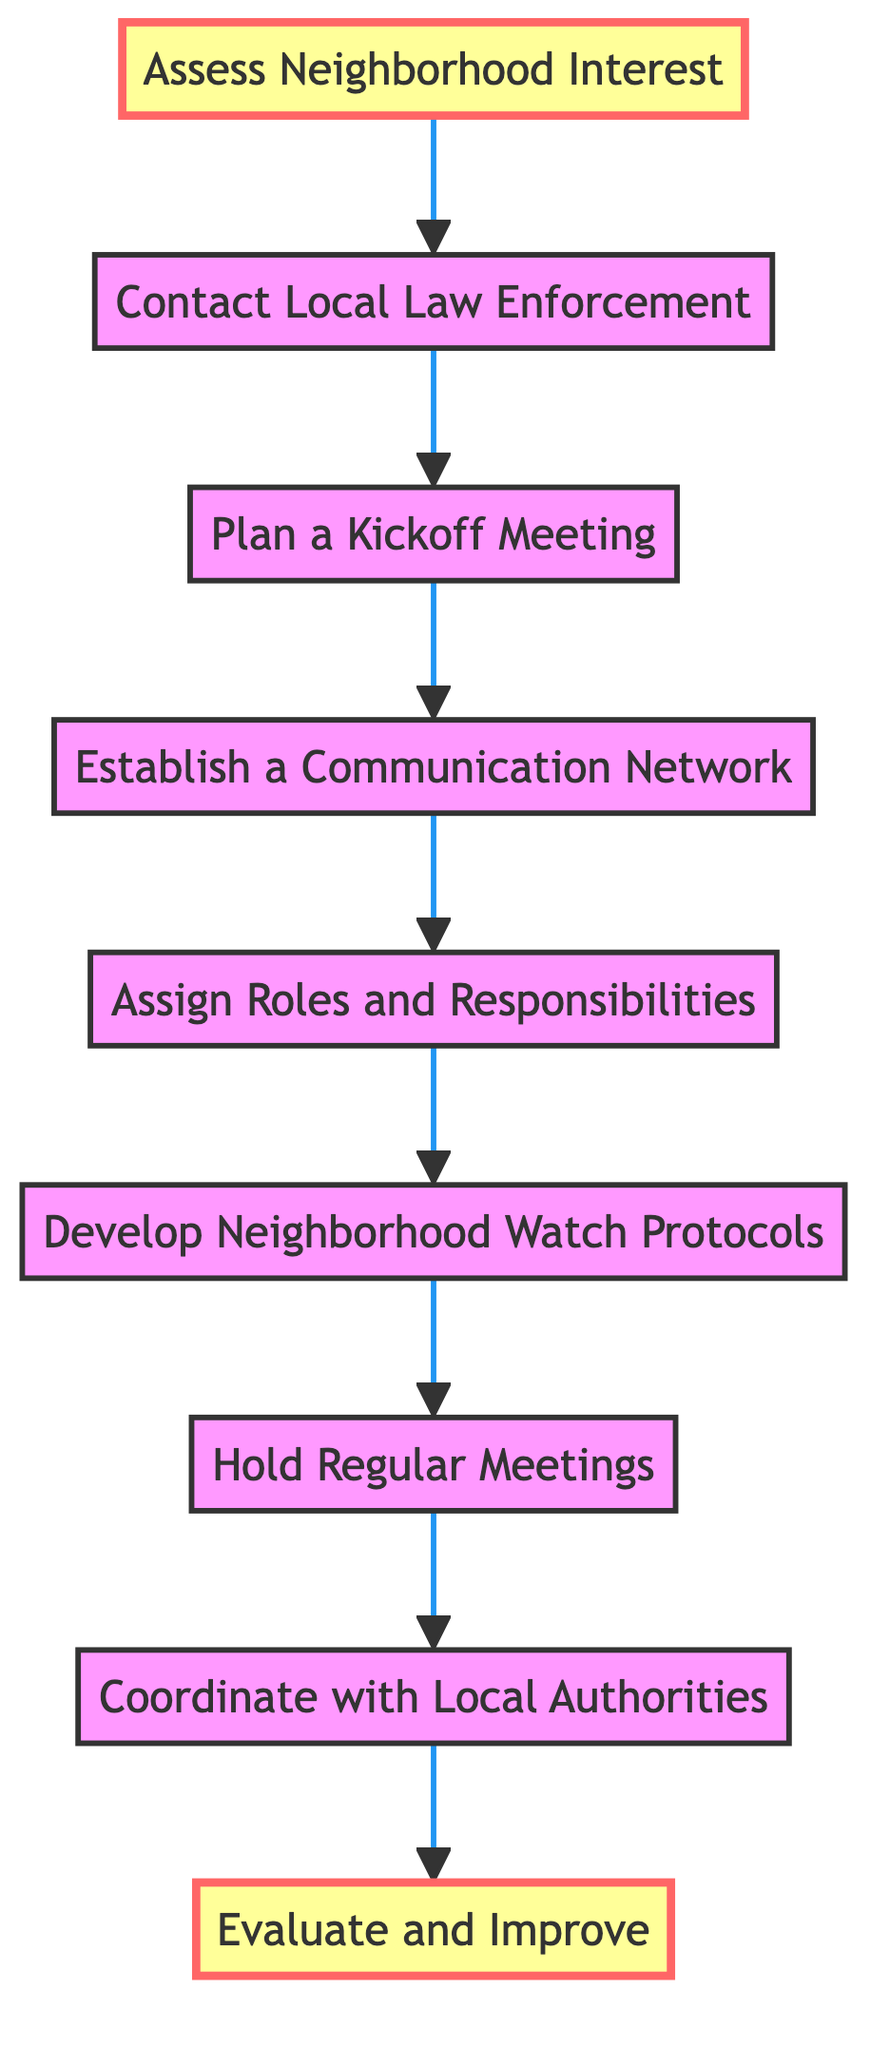What is the first step in the neighborhood watch program? The diagram starts with the first node labeled "Assess Neighborhood Interest," indicating that this is the initial step.
Answer: Assess Neighborhood Interest How many steps are in the neighborhood watch program? By counting the nodes in the flowchart, there are a total of nine steps represented.
Answer: Nine What step comes after "Plan a Kickoff Meeting"? The diagram shows that "Establish a Communication Network" is the next step that follows directly after the "Plan a Kickoff Meeting" node.
Answer: Establish a Communication Network Which step requires setting up a communication system? The node labeled "Establish a Communication Network" specifies the task of setting up communication systems, which matches the question.
Answer: Establish a Communication Network What step follows "Coordinate with Local Authorities"? According to the flowchart, after "Coordinate with Local Authorities," the program leads to the step "Evaluate and Improve," thus making this the subsequent step after coordination.
Answer: Evaluate and Improve Which step shows that roles are designated? The "Assign Roles and Responsibilities" node indicates the specific process of designating roles within the neighborhood watch program.
Answer: Assign Roles and Responsibilities What is the purpose of developing neighborhood watch protocols? The node "Develop Neighborhood Watch Protocols" focuses on creating guidelines, which signifies its purpose in the flow of the program.
Answer: Creating guidelines How is the neighborhood watch program evaluated? The diagram indicates that the evaluation process is captured in the "Evaluate and Improve" step, which emphasizes periodic assessments based on feedback.
Answer: Evaluate and Improve What role does local law enforcement play in organizing the program? According to the flowchart, local law enforcement is contacted during the "Contact Local Law Enforcement" step, highlighting their supportive role in organizing the neighborhood watch program.
Answer: Supportive role 